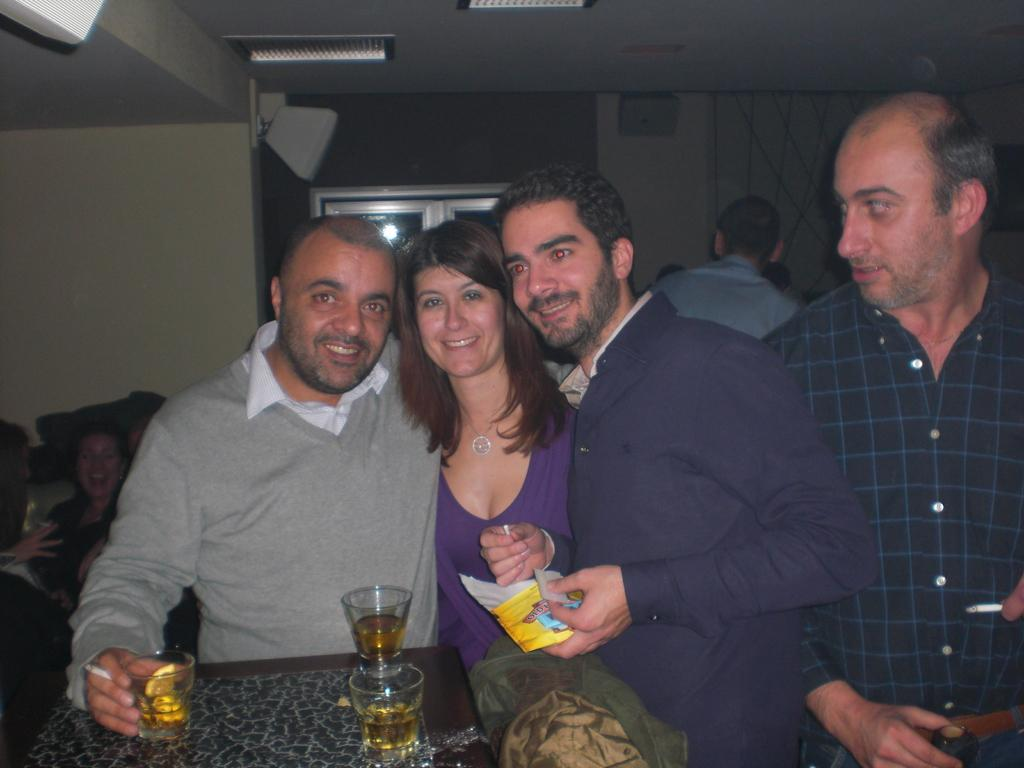How many people are present in the image? There are four people in the image. What is located in the image besides the people? There is a table in the image. What is on the table? There are glasses with drinks on the table. What can be seen in the background of the image? In the background, there are people visible, a wall, lights, and objects. What type of scale is visible in the image? There is no scale present in the image. What is the curve of the table in the image? The table in the image does not have a curve; it is a flat surface. 